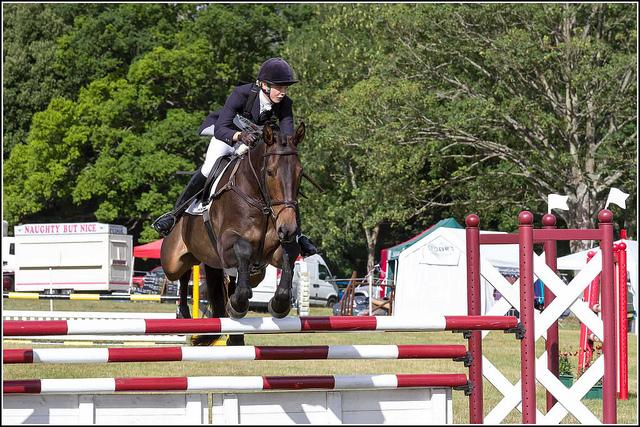What is this sport called? Please explain your reasoning. jumping. The sport is jumping. 